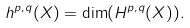<formula> <loc_0><loc_0><loc_500><loc_500>h ^ { p , q } ( X ) = \dim ( H ^ { p , q } ( X ) ) .</formula> 